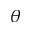Convert formula to latex. <formula><loc_0><loc_0><loc_500><loc_500>\theta</formula> 